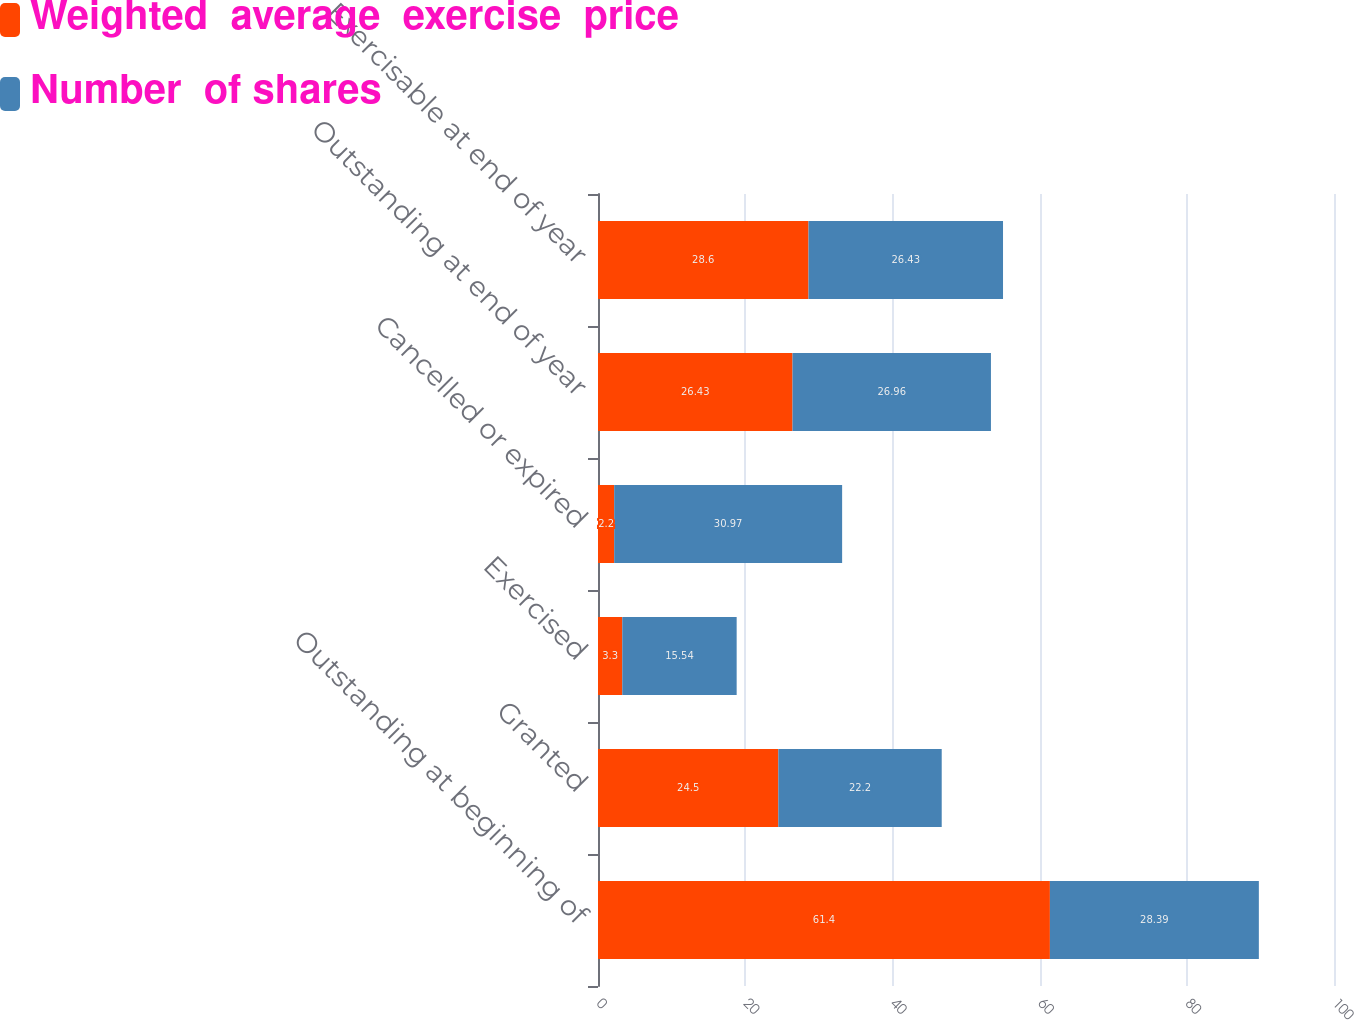Convert chart. <chart><loc_0><loc_0><loc_500><loc_500><stacked_bar_chart><ecel><fcel>Outstanding at beginning of<fcel>Granted<fcel>Exercised<fcel>Cancelled or expired<fcel>Outstanding at end of year<fcel>Exercisable at end of year<nl><fcel>Weighted  average  exercise  price<fcel>61.4<fcel>24.5<fcel>3.3<fcel>2.2<fcel>26.43<fcel>28.6<nl><fcel>Number  of shares<fcel>28.39<fcel>22.2<fcel>15.54<fcel>30.97<fcel>26.96<fcel>26.43<nl></chart> 